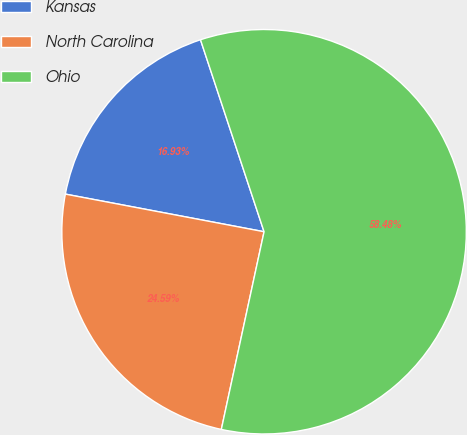Convert chart to OTSL. <chart><loc_0><loc_0><loc_500><loc_500><pie_chart><fcel>Kansas<fcel>North Carolina<fcel>Ohio<nl><fcel>16.93%<fcel>24.59%<fcel>58.48%<nl></chart> 